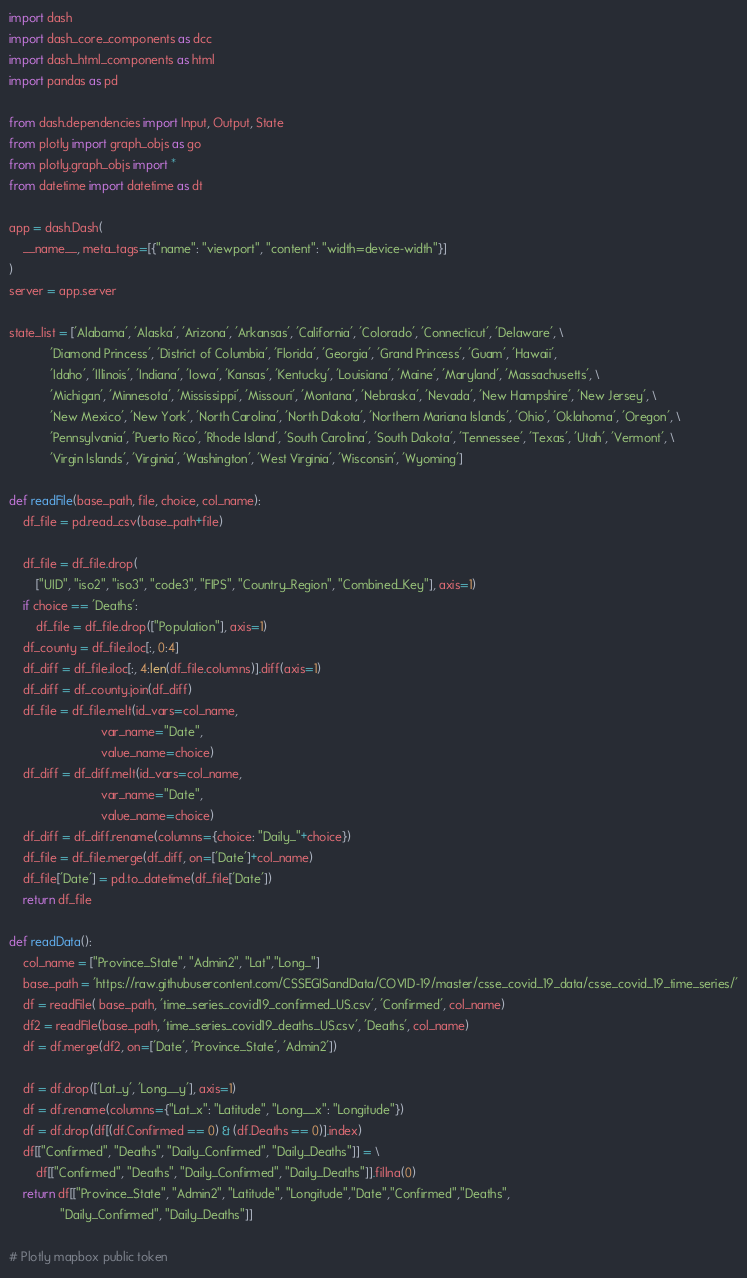Convert code to text. <code><loc_0><loc_0><loc_500><loc_500><_Python_>import dash
import dash_core_components as dcc
import dash_html_components as html
import pandas as pd

from dash.dependencies import Input, Output, State
from plotly import graph_objs as go
from plotly.graph_objs import *
from datetime import datetime as dt

app = dash.Dash(
    __name__, meta_tags=[{"name": "viewport", "content": "width=device-width"}]
)
server = app.server

state_list = ['Alabama', 'Alaska', 'Arizona', 'Arkansas', 'California', 'Colorado', 'Connecticut', 'Delaware', \
            'Diamond Princess', 'District of Columbia', 'Florida', 'Georgia', 'Grand Princess', 'Guam', 'Hawaii', 
            'Idaho', 'Illinois', 'Indiana', 'Iowa', 'Kansas', 'Kentucky', 'Louisiana', 'Maine', 'Maryland', 'Massachusetts', \
            'Michigan', 'Minnesota', 'Mississippi', 'Missouri', 'Montana', 'Nebraska', 'Nevada', 'New Hampshire', 'New Jersey', \
            'New Mexico', 'New York', 'North Carolina', 'North Dakota', 'Northern Mariana Islands', 'Ohio', 'Oklahoma', 'Oregon', \
            'Pennsylvania', 'Puerto Rico', 'Rhode Island', 'South Carolina', 'South Dakota', 'Tennessee', 'Texas', 'Utah', 'Vermont', \
            'Virgin Islands', 'Virginia', 'Washington', 'West Virginia', 'Wisconsin', 'Wyoming']

def readFile(base_path, file, choice, col_name):
    df_file = pd.read_csv(base_path+file)

    df_file = df_file.drop(
        ["UID", "iso2", "iso3", "code3", "FIPS", "Country_Region", "Combined_Key"], axis=1)
    if choice == 'Deaths':
        df_file = df_file.drop(["Population"], axis=1)
    df_county = df_file.iloc[:, 0:4]
    df_diff = df_file.iloc[:, 4:len(df_file.columns)].diff(axis=1)
    df_diff = df_county.join(df_diff)
    df_file = df_file.melt(id_vars=col_name,
                           var_name="Date",
                           value_name=choice)
    df_diff = df_diff.melt(id_vars=col_name,
                           var_name="Date",
                           value_name=choice)
    df_diff = df_diff.rename(columns={choice: "Daily_"+choice})
    df_file = df_file.merge(df_diff, on=['Date']+col_name)
    df_file['Date'] = pd.to_datetime(df_file['Date'])
    return df_file

def readData():
    col_name = ["Province_State", "Admin2", "Lat","Long_"]
    base_path = 'https://raw.githubusercontent.com/CSSEGISandData/COVID-19/master/csse_covid_19_data/csse_covid_19_time_series/'
    df = readFile( base_path, 'time_series_covid19_confirmed_US.csv', 'Confirmed', col_name)
    df2 = readFile(base_path, 'time_series_covid19_deaths_US.csv', 'Deaths', col_name)
    df = df.merge(df2, on=['Date', 'Province_State', 'Admin2'])

    df = df.drop(['Lat_y', 'Long__y'], axis=1)
    df = df.rename(columns={"Lat_x": "Latitude", "Long__x": "Longitude"})
    df = df.drop(df[(df.Confirmed == 0) & (df.Deaths == 0)].index)
    df[["Confirmed", "Deaths", "Daily_Confirmed", "Daily_Deaths"]] = \
        df[["Confirmed", "Deaths", "Daily_Confirmed", "Daily_Deaths"]].fillna(0)
    return df[["Province_State", "Admin2", "Latitude", "Longitude","Date","Confirmed","Deaths",
               "Daily_Confirmed", "Daily_Deaths"]]

# Plotly mapbox public token</code> 